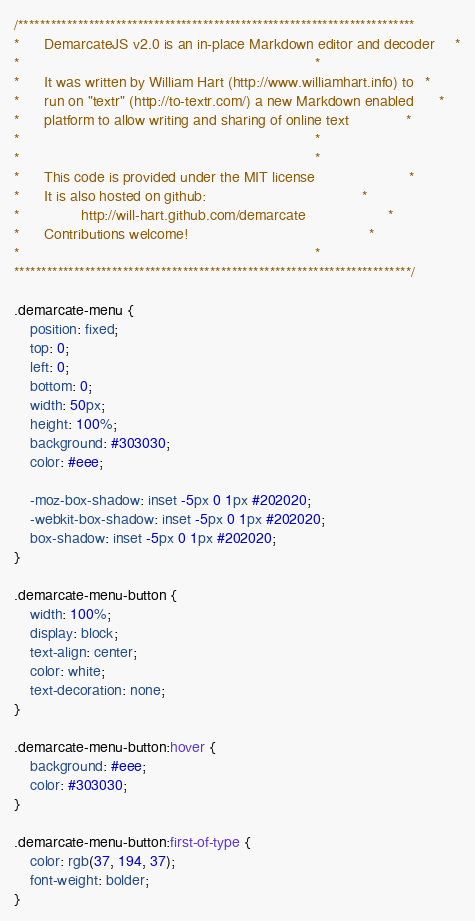<code> <loc_0><loc_0><loc_500><loc_500><_CSS_>/*************************************************************************
*      DemarcateJS v2.0 is an in-place Markdown editor and decoder     *
*                                                                        *
*      It was written by William Hart (http://www.williamhart.info) to   *
*      run on "textr" (http://to-textr.com/) a new Markdown enabled      *
*      platform to allow writing and sharing of online text              *
*                                                                        *
*                                                                        *
*      This code is provided under the MIT license                       *
*      It is also hosted on github:                                      *
*               http://will-hart.github.com/demarcate                    *
*      Contributions welcome!                                            *
*                                                                        *
*************************************************************************/

.demarcate-menu {
	position: fixed;
	top: 0;
	left: 0;
	bottom: 0;
	width: 50px;
	height: 100%;
	background: #303030;
	color: #eee;
	
	-moz-box-shadow: inset -5px 0 1px #202020;
	-webkit-box-shadow: inset -5px 0 1px #202020;
	box-shadow: inset -5px 0 1px #202020;
}

.demarcate-menu-button {
	width: 100%;
	display: block;
	text-align: center;
	color: white;
	text-decoration: none;
}

.demarcate-menu-button:hover {
	background: #eee;
	color: #303030;
}

.demarcate-menu-button:first-of-type {
	color: rgb(37, 194, 37);
	font-weight: bolder;
}</code> 